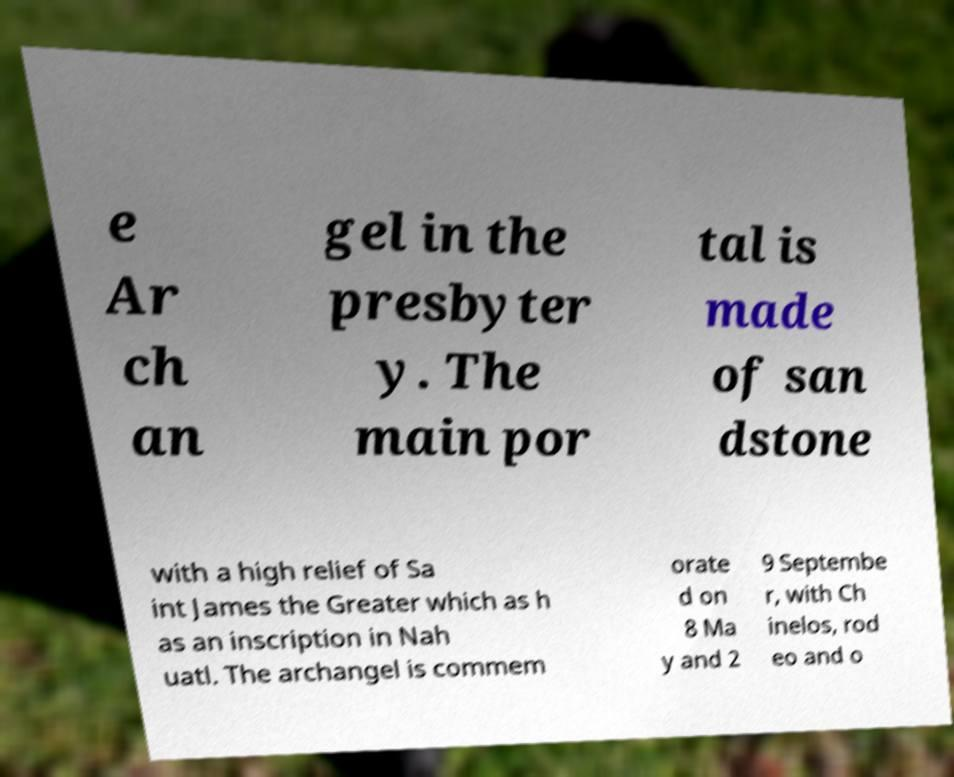For documentation purposes, I need the text within this image transcribed. Could you provide that? e Ar ch an gel in the presbyter y. The main por tal is made of san dstone with a high relief of Sa int James the Greater which as h as an inscription in Nah uatl. The archangel is commem orate d on 8 Ma y and 2 9 Septembe r, with Ch inelos, rod eo and o 